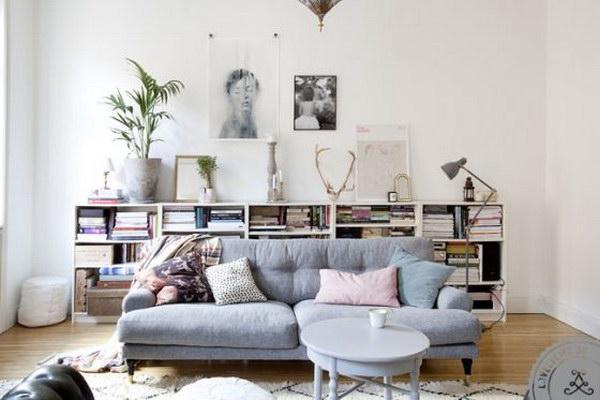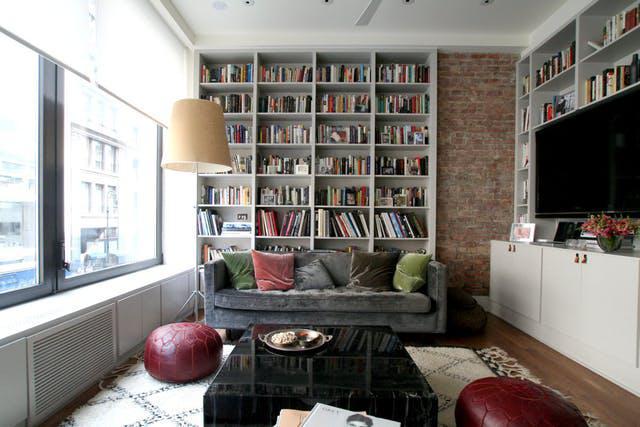The first image is the image on the left, the second image is the image on the right. For the images shown, is this caption "A room includes a round table in front of a neutral couch, which sits in front of a wall-filling white bookcase and something olive-green." true? Answer yes or no. No. The first image is the image on the left, the second image is the image on the right. Analyze the images presented: Is the assertion "In one image a couch sits across the end of a room with white shelves on the wall behind and the wall to the side." valid? Answer yes or no. Yes. 